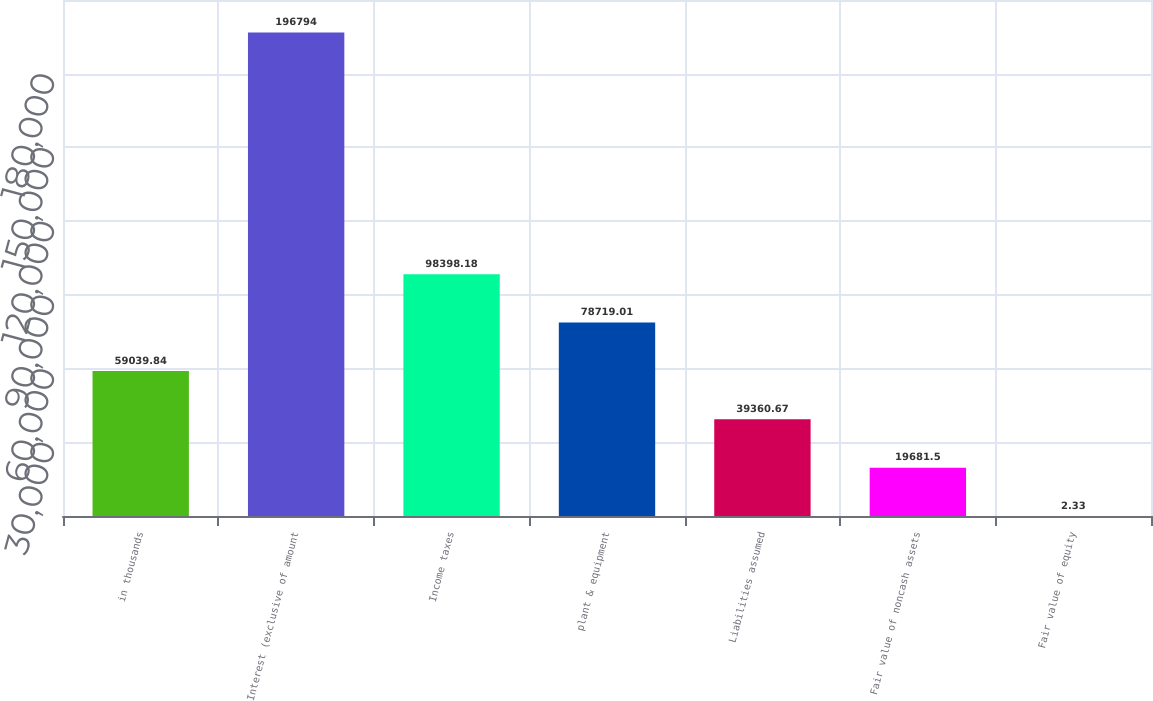Convert chart. <chart><loc_0><loc_0><loc_500><loc_500><bar_chart><fcel>in thousands<fcel>Interest (exclusive of amount<fcel>Income taxes<fcel>plant & equipment<fcel>Liabilities assumed<fcel>Fair value of noncash assets<fcel>Fair value of equity<nl><fcel>59039.8<fcel>196794<fcel>98398.2<fcel>78719<fcel>39360.7<fcel>19681.5<fcel>2.33<nl></chart> 